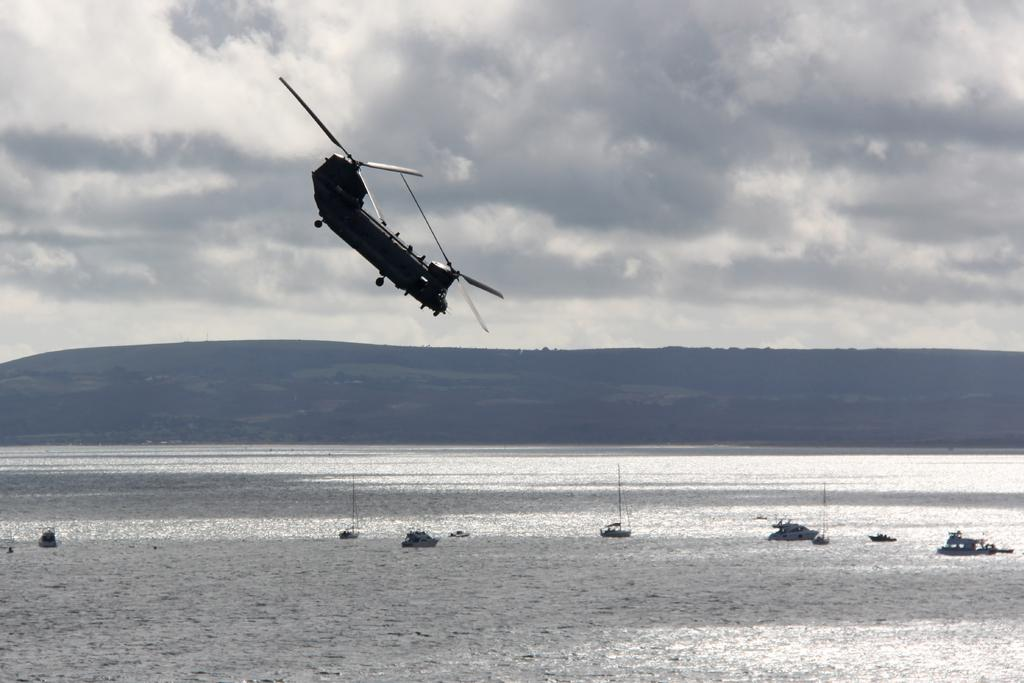What is flying in the air in the image? There is a helicopter flying in the air in the image. What is located at the bottom of the image? There are boats in the water at the bottom of the image. What can be seen in the background of the image? There are hills visible in the background. What is visible at the top of the image? The sky is visible at the top of the image. What type of cord is being used by the helicopter in the image? There is no cord visible in the image; the helicopter is flying without any visible cords. What part of the body is missing from the boats in the image? Boats do not have body parts like arms, so this question is not applicable to the image. 